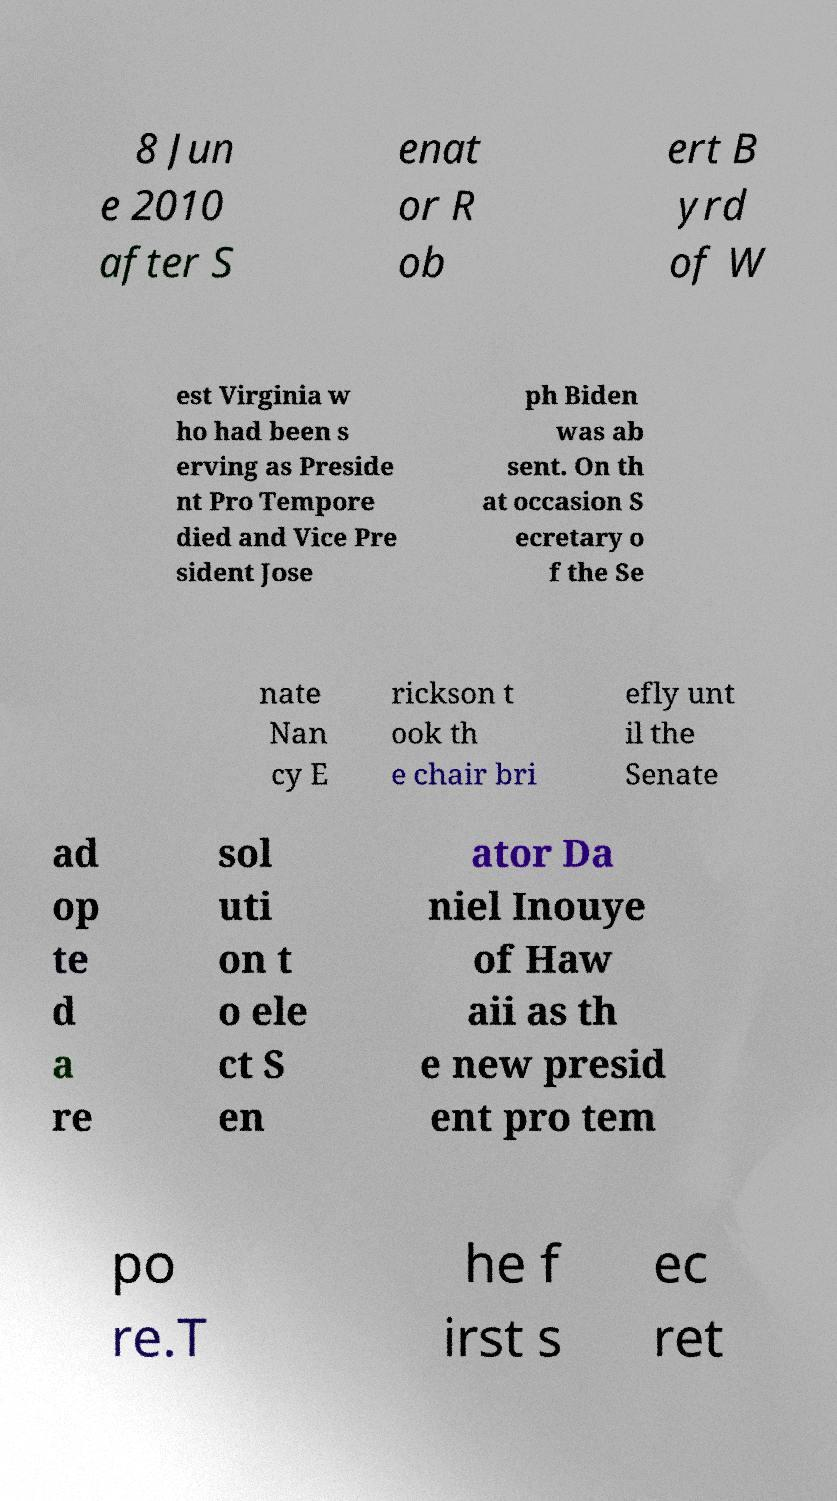Can you read and provide the text displayed in the image?This photo seems to have some interesting text. Can you extract and type it out for me? 8 Jun e 2010 after S enat or R ob ert B yrd of W est Virginia w ho had been s erving as Preside nt Pro Tempore died and Vice Pre sident Jose ph Biden was ab sent. On th at occasion S ecretary o f the Se nate Nan cy E rickson t ook th e chair bri efly unt il the Senate ad op te d a re sol uti on t o ele ct S en ator Da niel Inouye of Haw aii as th e new presid ent pro tem po re.T he f irst s ec ret 